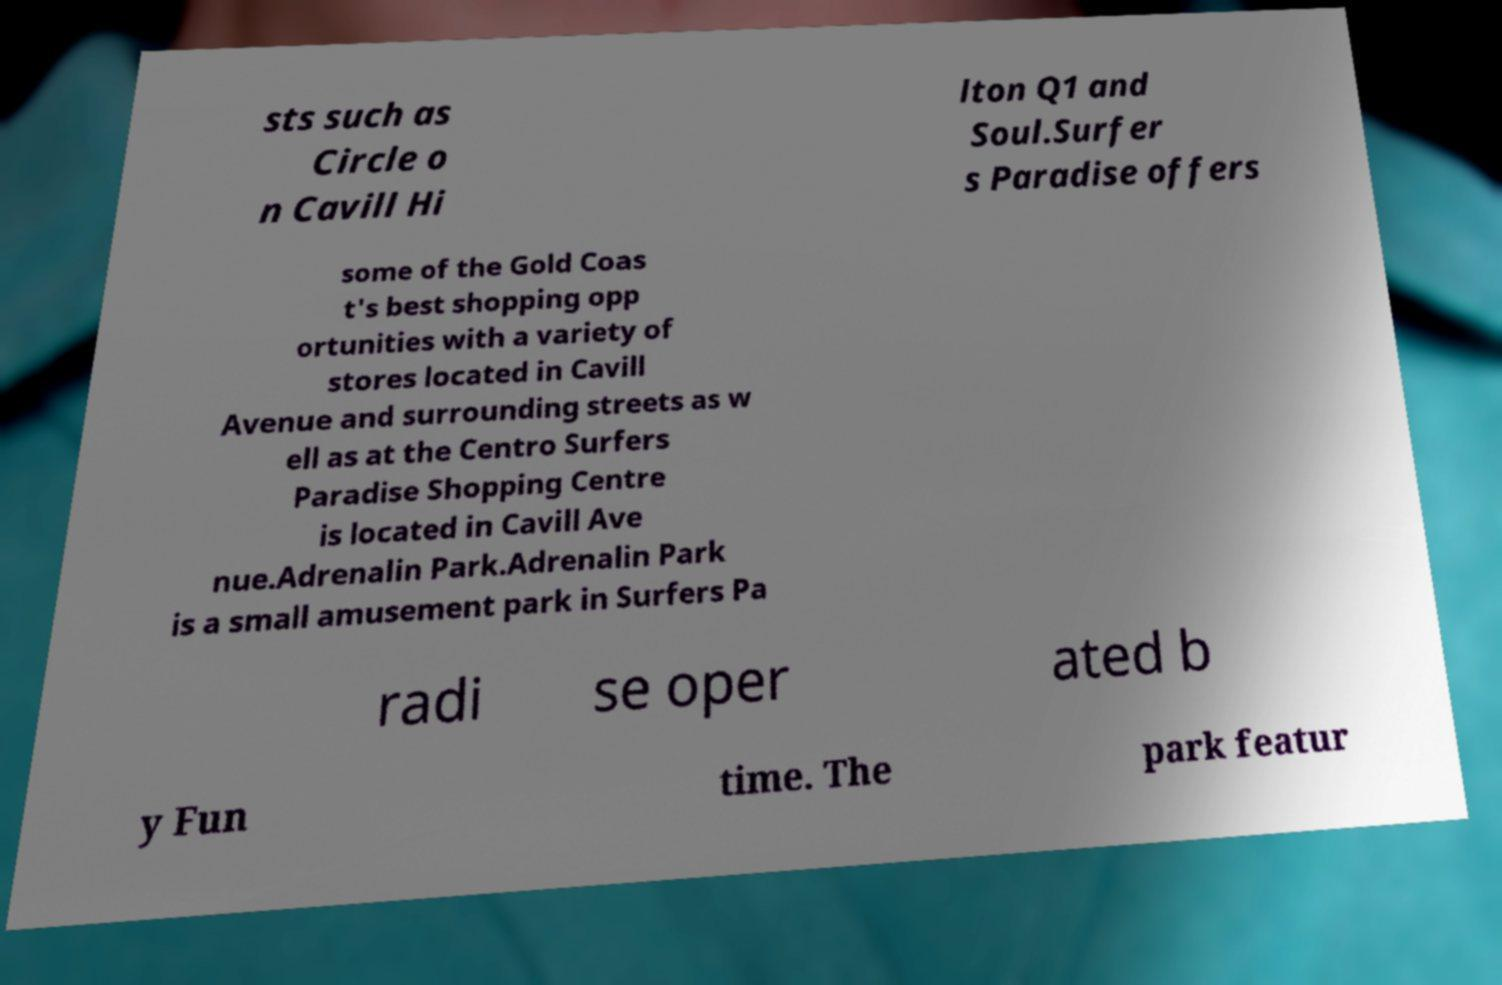There's text embedded in this image that I need extracted. Can you transcribe it verbatim? sts such as Circle o n Cavill Hi lton Q1 and Soul.Surfer s Paradise offers some of the Gold Coas t's best shopping opp ortunities with a variety of stores located in Cavill Avenue and surrounding streets as w ell as at the Centro Surfers Paradise Shopping Centre is located in Cavill Ave nue.Adrenalin Park.Adrenalin Park is a small amusement park in Surfers Pa radi se oper ated b y Fun time. The park featur 